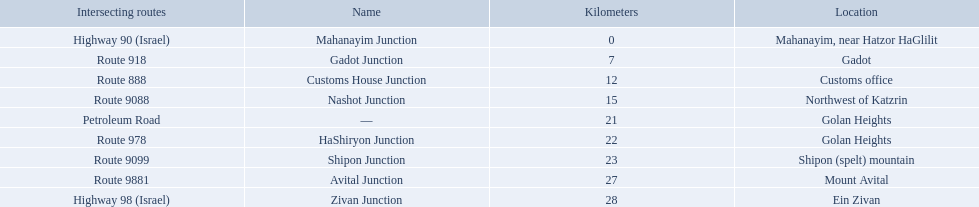What are all of the junction names? Mahanayim Junction, Gadot Junction, Customs House Junction, Nashot Junction, —, HaShiryon Junction, Shipon Junction, Avital Junction, Zivan Junction. Can you give me this table in json format? {'header': ['Intersecting routes', 'Name', 'Kilometers', 'Location'], 'rows': [['Highway 90 (Israel)', 'Mahanayim Junction', '0', 'Mahanayim, near Hatzor HaGlilit'], ['Route 918', 'Gadot Junction', '7', 'Gadot'], ['Route 888', 'Customs House Junction', '12', 'Customs office'], ['Route 9088', 'Nashot Junction', '15', 'Northwest of Katzrin'], ['Petroleum Road', '—', '21', 'Golan Heights'], ['Route 978', 'HaShiryon Junction', '22', 'Golan Heights'], ['Route 9099', 'Shipon Junction', '23', 'Shipon (spelt) mountain'], ['Route 9881', 'Avital Junction', '27', 'Mount Avital'], ['Highway 98 (Israel)', 'Zivan Junction', '28', 'Ein Zivan']]} What are their locations in kilometers? 0, 7, 12, 15, 21, 22, 23, 27, 28. Between shipon and avital, whicih is nashot closer to? Shipon Junction. 